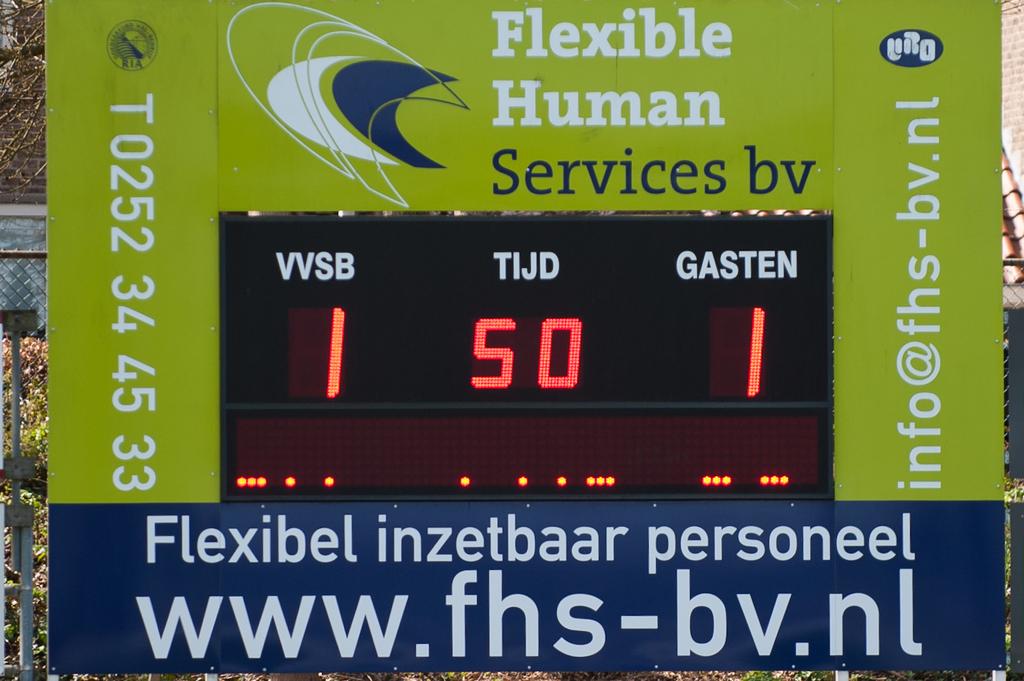What is the website?
Your answer should be compact. Www.fhs-bv.nl. 